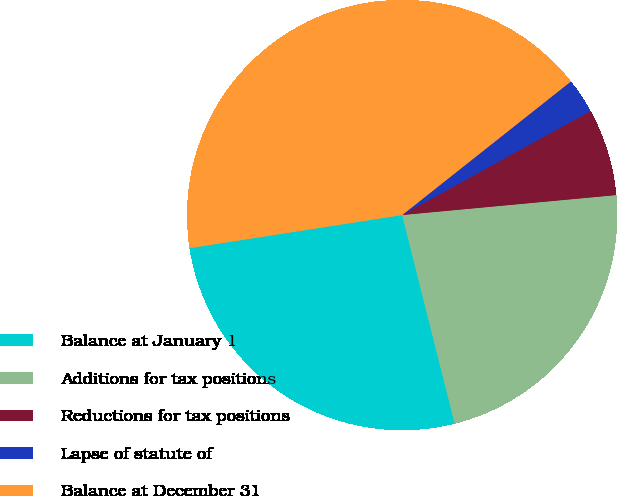<chart> <loc_0><loc_0><loc_500><loc_500><pie_chart><fcel>Balance at January 1<fcel>Additions for tax positions<fcel>Reductions for tax positions<fcel>Lapse of statute of<fcel>Balance at December 31<nl><fcel>26.47%<fcel>22.55%<fcel>6.55%<fcel>2.63%<fcel>41.81%<nl></chart> 